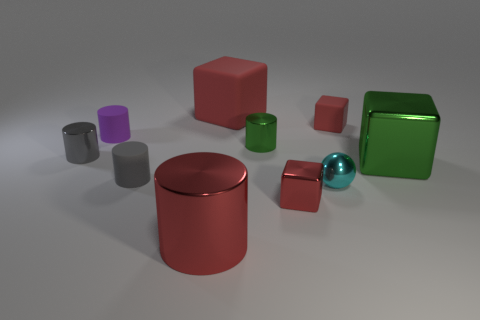How many objects are either red metal things that are right of the big metallic cylinder or big red things on the right side of the red metallic cylinder?
Your answer should be very brief. 2. Do the purple object and the green metal cylinder have the same size?
Provide a short and direct response. Yes. Are there any other things that are the same size as the red metal cylinder?
Ensure brevity in your answer.  Yes. There is a red thing that is on the right side of the tiny red metallic object; does it have the same shape as the big red object that is to the left of the big rubber object?
Make the answer very short. No. How big is the purple cylinder?
Provide a short and direct response. Small. There is a tiny red thing behind the green thing in front of the tiny cylinder right of the big red metallic cylinder; what is it made of?
Provide a succinct answer. Rubber. What number of other objects are there of the same color as the large metal cylinder?
Offer a terse response. 3. What number of blue things are tiny shiny blocks or metallic things?
Keep it short and to the point. 0. There is a small gray cylinder that is behind the green block; what material is it?
Your answer should be compact. Metal. Is the tiny gray cylinder on the right side of the purple thing made of the same material as the small cyan ball?
Provide a succinct answer. No. 